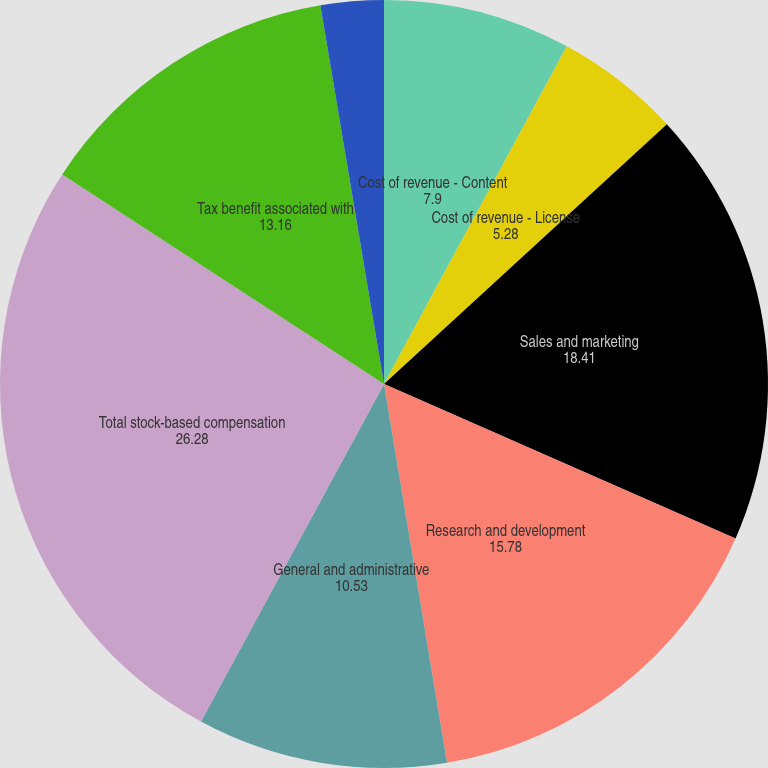<chart> <loc_0><loc_0><loc_500><loc_500><pie_chart><fcel>Cost of revenue - Content<fcel>Cost of revenue - License<fcel>Sales and marketing<fcel>Research and development<fcel>General and administrative<fcel>Total stock-based compensation<fcel>Tax benefit associated with<fcel>Net stock-based compensation<nl><fcel>7.9%<fcel>5.28%<fcel>18.41%<fcel>15.78%<fcel>10.53%<fcel>26.28%<fcel>13.16%<fcel>2.65%<nl></chart> 